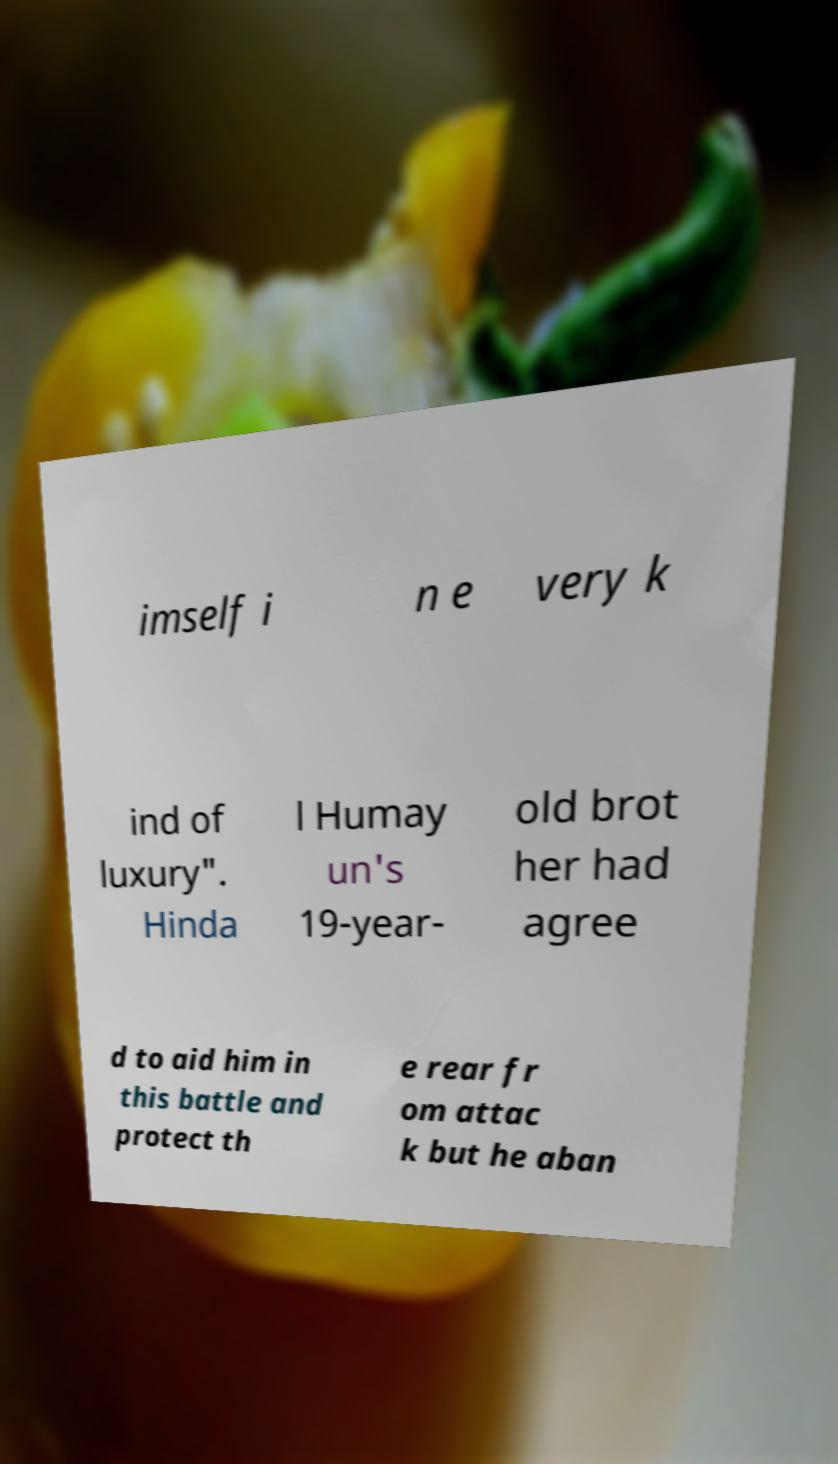Can you read and provide the text displayed in the image?This photo seems to have some interesting text. Can you extract and type it out for me? imself i n e very k ind of luxury". Hinda l Humay un's 19-year- old brot her had agree d to aid him in this battle and protect th e rear fr om attac k but he aban 